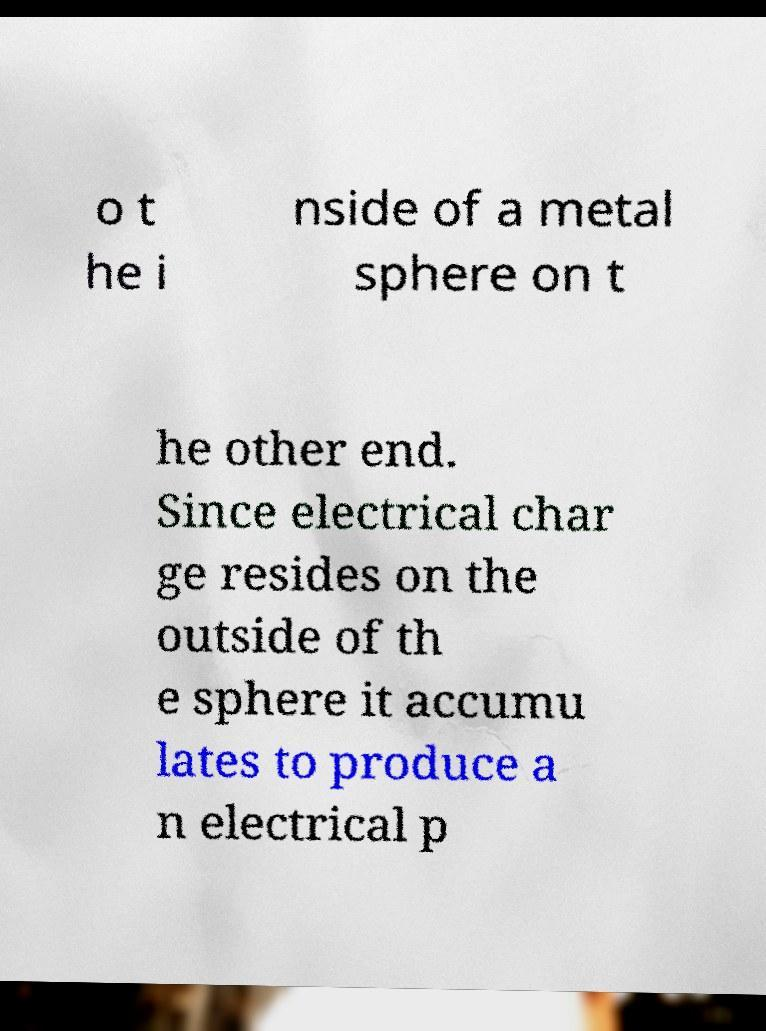Please identify and transcribe the text found in this image. o t he i nside of a metal sphere on t he other end. Since electrical char ge resides on the outside of th e sphere it accumu lates to produce a n electrical p 